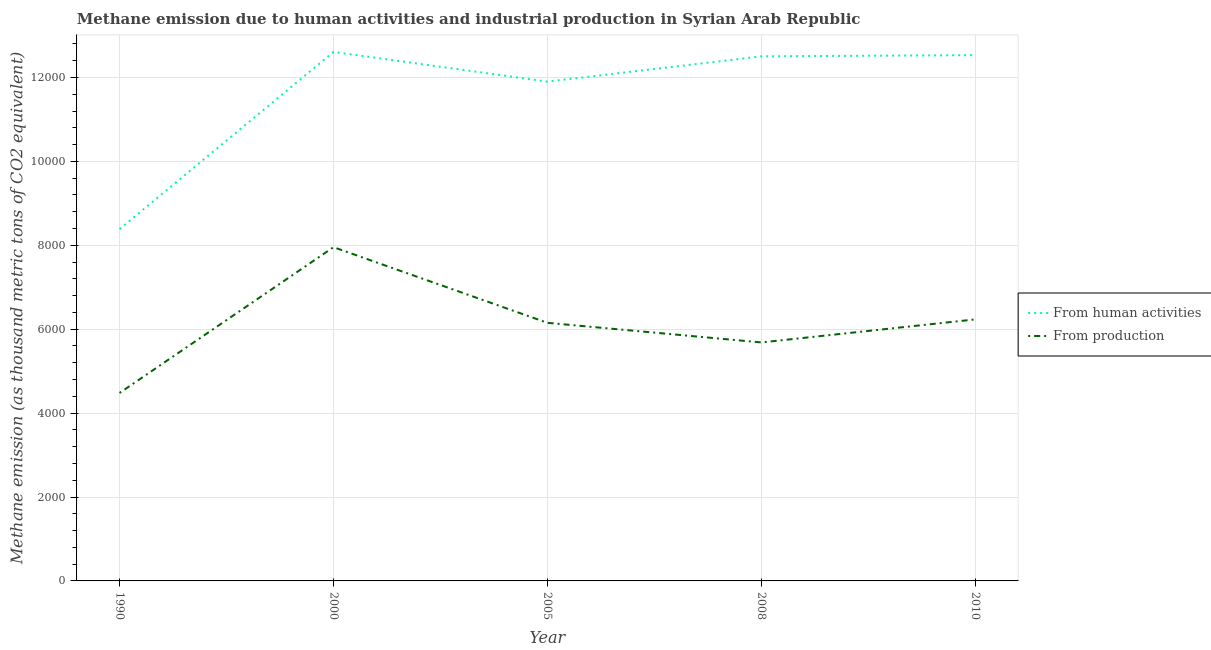Is the number of lines equal to the number of legend labels?
Your answer should be very brief. Yes. What is the amount of emissions from human activities in 2005?
Offer a terse response. 1.19e+04. Across all years, what is the maximum amount of emissions generated from industries?
Keep it short and to the point. 7954.6. Across all years, what is the minimum amount of emissions generated from industries?
Make the answer very short. 4480.2. In which year was the amount of emissions generated from industries maximum?
Your answer should be compact. 2000. What is the total amount of emissions from human activities in the graph?
Offer a terse response. 5.79e+04. What is the difference between the amount of emissions from human activities in 2005 and that in 2008?
Provide a short and direct response. -602.6. What is the difference between the amount of emissions from human activities in 2000 and the amount of emissions generated from industries in 2010?
Keep it short and to the point. 6375.2. What is the average amount of emissions generated from industries per year?
Your answer should be compact. 6100.92. In the year 2000, what is the difference between the amount of emissions from human activities and amount of emissions generated from industries?
Provide a succinct answer. 4654.2. In how many years, is the amount of emissions generated from industries greater than 2400 thousand metric tons?
Your answer should be very brief. 5. What is the ratio of the amount of emissions generated from industries in 1990 to that in 2008?
Offer a terse response. 0.79. What is the difference between the highest and the second highest amount of emissions from human activities?
Offer a terse response. 76.7. What is the difference between the highest and the lowest amount of emissions generated from industries?
Offer a very short reply. 3474.4. In how many years, is the amount of emissions from human activities greater than the average amount of emissions from human activities taken over all years?
Provide a short and direct response. 4. Does the amount of emissions from human activities monotonically increase over the years?
Ensure brevity in your answer.  No. Is the amount of emissions generated from industries strictly greater than the amount of emissions from human activities over the years?
Provide a succinct answer. No. What is the title of the graph?
Offer a terse response. Methane emission due to human activities and industrial production in Syrian Arab Republic. What is the label or title of the X-axis?
Provide a succinct answer. Year. What is the label or title of the Y-axis?
Provide a succinct answer. Methane emission (as thousand metric tons of CO2 equivalent). What is the Methane emission (as thousand metric tons of CO2 equivalent) in From human activities in 1990?
Your answer should be very brief. 8384.9. What is the Methane emission (as thousand metric tons of CO2 equivalent) in From production in 1990?
Provide a short and direct response. 4480.2. What is the Methane emission (as thousand metric tons of CO2 equivalent) in From human activities in 2000?
Keep it short and to the point. 1.26e+04. What is the Methane emission (as thousand metric tons of CO2 equivalent) of From production in 2000?
Keep it short and to the point. 7954.6. What is the Methane emission (as thousand metric tons of CO2 equivalent) in From human activities in 2005?
Provide a succinct answer. 1.19e+04. What is the Methane emission (as thousand metric tons of CO2 equivalent) of From production in 2005?
Provide a short and direct response. 6151.7. What is the Methane emission (as thousand metric tons of CO2 equivalent) in From human activities in 2008?
Offer a terse response. 1.25e+04. What is the Methane emission (as thousand metric tons of CO2 equivalent) of From production in 2008?
Your answer should be compact. 5684.5. What is the Methane emission (as thousand metric tons of CO2 equivalent) of From human activities in 2010?
Provide a succinct answer. 1.25e+04. What is the Methane emission (as thousand metric tons of CO2 equivalent) of From production in 2010?
Provide a succinct answer. 6233.6. Across all years, what is the maximum Methane emission (as thousand metric tons of CO2 equivalent) in From human activities?
Your answer should be very brief. 1.26e+04. Across all years, what is the maximum Methane emission (as thousand metric tons of CO2 equivalent) of From production?
Keep it short and to the point. 7954.6. Across all years, what is the minimum Methane emission (as thousand metric tons of CO2 equivalent) in From human activities?
Give a very brief answer. 8384.9. Across all years, what is the minimum Methane emission (as thousand metric tons of CO2 equivalent) of From production?
Make the answer very short. 4480.2. What is the total Methane emission (as thousand metric tons of CO2 equivalent) in From human activities in the graph?
Provide a succinct answer. 5.79e+04. What is the total Methane emission (as thousand metric tons of CO2 equivalent) of From production in the graph?
Provide a succinct answer. 3.05e+04. What is the difference between the Methane emission (as thousand metric tons of CO2 equivalent) of From human activities in 1990 and that in 2000?
Provide a short and direct response. -4223.9. What is the difference between the Methane emission (as thousand metric tons of CO2 equivalent) in From production in 1990 and that in 2000?
Provide a succinct answer. -3474.4. What is the difference between the Methane emission (as thousand metric tons of CO2 equivalent) in From human activities in 1990 and that in 2005?
Make the answer very short. -3516.3. What is the difference between the Methane emission (as thousand metric tons of CO2 equivalent) of From production in 1990 and that in 2005?
Ensure brevity in your answer.  -1671.5. What is the difference between the Methane emission (as thousand metric tons of CO2 equivalent) in From human activities in 1990 and that in 2008?
Provide a short and direct response. -4118.9. What is the difference between the Methane emission (as thousand metric tons of CO2 equivalent) of From production in 1990 and that in 2008?
Provide a short and direct response. -1204.3. What is the difference between the Methane emission (as thousand metric tons of CO2 equivalent) of From human activities in 1990 and that in 2010?
Provide a succinct answer. -4147.2. What is the difference between the Methane emission (as thousand metric tons of CO2 equivalent) in From production in 1990 and that in 2010?
Provide a short and direct response. -1753.4. What is the difference between the Methane emission (as thousand metric tons of CO2 equivalent) of From human activities in 2000 and that in 2005?
Your answer should be compact. 707.6. What is the difference between the Methane emission (as thousand metric tons of CO2 equivalent) of From production in 2000 and that in 2005?
Give a very brief answer. 1802.9. What is the difference between the Methane emission (as thousand metric tons of CO2 equivalent) of From human activities in 2000 and that in 2008?
Make the answer very short. 105. What is the difference between the Methane emission (as thousand metric tons of CO2 equivalent) in From production in 2000 and that in 2008?
Give a very brief answer. 2270.1. What is the difference between the Methane emission (as thousand metric tons of CO2 equivalent) of From human activities in 2000 and that in 2010?
Keep it short and to the point. 76.7. What is the difference between the Methane emission (as thousand metric tons of CO2 equivalent) of From production in 2000 and that in 2010?
Offer a very short reply. 1721. What is the difference between the Methane emission (as thousand metric tons of CO2 equivalent) of From human activities in 2005 and that in 2008?
Provide a succinct answer. -602.6. What is the difference between the Methane emission (as thousand metric tons of CO2 equivalent) in From production in 2005 and that in 2008?
Give a very brief answer. 467.2. What is the difference between the Methane emission (as thousand metric tons of CO2 equivalent) of From human activities in 2005 and that in 2010?
Your answer should be compact. -630.9. What is the difference between the Methane emission (as thousand metric tons of CO2 equivalent) of From production in 2005 and that in 2010?
Make the answer very short. -81.9. What is the difference between the Methane emission (as thousand metric tons of CO2 equivalent) in From human activities in 2008 and that in 2010?
Your response must be concise. -28.3. What is the difference between the Methane emission (as thousand metric tons of CO2 equivalent) of From production in 2008 and that in 2010?
Make the answer very short. -549.1. What is the difference between the Methane emission (as thousand metric tons of CO2 equivalent) in From human activities in 1990 and the Methane emission (as thousand metric tons of CO2 equivalent) in From production in 2000?
Your answer should be very brief. 430.3. What is the difference between the Methane emission (as thousand metric tons of CO2 equivalent) in From human activities in 1990 and the Methane emission (as thousand metric tons of CO2 equivalent) in From production in 2005?
Provide a short and direct response. 2233.2. What is the difference between the Methane emission (as thousand metric tons of CO2 equivalent) in From human activities in 1990 and the Methane emission (as thousand metric tons of CO2 equivalent) in From production in 2008?
Give a very brief answer. 2700.4. What is the difference between the Methane emission (as thousand metric tons of CO2 equivalent) of From human activities in 1990 and the Methane emission (as thousand metric tons of CO2 equivalent) of From production in 2010?
Offer a terse response. 2151.3. What is the difference between the Methane emission (as thousand metric tons of CO2 equivalent) of From human activities in 2000 and the Methane emission (as thousand metric tons of CO2 equivalent) of From production in 2005?
Provide a short and direct response. 6457.1. What is the difference between the Methane emission (as thousand metric tons of CO2 equivalent) in From human activities in 2000 and the Methane emission (as thousand metric tons of CO2 equivalent) in From production in 2008?
Offer a very short reply. 6924.3. What is the difference between the Methane emission (as thousand metric tons of CO2 equivalent) in From human activities in 2000 and the Methane emission (as thousand metric tons of CO2 equivalent) in From production in 2010?
Offer a very short reply. 6375.2. What is the difference between the Methane emission (as thousand metric tons of CO2 equivalent) in From human activities in 2005 and the Methane emission (as thousand metric tons of CO2 equivalent) in From production in 2008?
Offer a very short reply. 6216.7. What is the difference between the Methane emission (as thousand metric tons of CO2 equivalent) in From human activities in 2005 and the Methane emission (as thousand metric tons of CO2 equivalent) in From production in 2010?
Provide a succinct answer. 5667.6. What is the difference between the Methane emission (as thousand metric tons of CO2 equivalent) in From human activities in 2008 and the Methane emission (as thousand metric tons of CO2 equivalent) in From production in 2010?
Your answer should be very brief. 6270.2. What is the average Methane emission (as thousand metric tons of CO2 equivalent) of From human activities per year?
Ensure brevity in your answer.  1.16e+04. What is the average Methane emission (as thousand metric tons of CO2 equivalent) in From production per year?
Offer a very short reply. 6100.92. In the year 1990, what is the difference between the Methane emission (as thousand metric tons of CO2 equivalent) in From human activities and Methane emission (as thousand metric tons of CO2 equivalent) in From production?
Give a very brief answer. 3904.7. In the year 2000, what is the difference between the Methane emission (as thousand metric tons of CO2 equivalent) of From human activities and Methane emission (as thousand metric tons of CO2 equivalent) of From production?
Your answer should be compact. 4654.2. In the year 2005, what is the difference between the Methane emission (as thousand metric tons of CO2 equivalent) in From human activities and Methane emission (as thousand metric tons of CO2 equivalent) in From production?
Your response must be concise. 5749.5. In the year 2008, what is the difference between the Methane emission (as thousand metric tons of CO2 equivalent) of From human activities and Methane emission (as thousand metric tons of CO2 equivalent) of From production?
Offer a terse response. 6819.3. In the year 2010, what is the difference between the Methane emission (as thousand metric tons of CO2 equivalent) in From human activities and Methane emission (as thousand metric tons of CO2 equivalent) in From production?
Your response must be concise. 6298.5. What is the ratio of the Methane emission (as thousand metric tons of CO2 equivalent) in From human activities in 1990 to that in 2000?
Your response must be concise. 0.67. What is the ratio of the Methane emission (as thousand metric tons of CO2 equivalent) of From production in 1990 to that in 2000?
Your answer should be compact. 0.56. What is the ratio of the Methane emission (as thousand metric tons of CO2 equivalent) of From human activities in 1990 to that in 2005?
Your response must be concise. 0.7. What is the ratio of the Methane emission (as thousand metric tons of CO2 equivalent) in From production in 1990 to that in 2005?
Keep it short and to the point. 0.73. What is the ratio of the Methane emission (as thousand metric tons of CO2 equivalent) of From human activities in 1990 to that in 2008?
Ensure brevity in your answer.  0.67. What is the ratio of the Methane emission (as thousand metric tons of CO2 equivalent) of From production in 1990 to that in 2008?
Make the answer very short. 0.79. What is the ratio of the Methane emission (as thousand metric tons of CO2 equivalent) of From human activities in 1990 to that in 2010?
Provide a succinct answer. 0.67. What is the ratio of the Methane emission (as thousand metric tons of CO2 equivalent) of From production in 1990 to that in 2010?
Make the answer very short. 0.72. What is the ratio of the Methane emission (as thousand metric tons of CO2 equivalent) in From human activities in 2000 to that in 2005?
Give a very brief answer. 1.06. What is the ratio of the Methane emission (as thousand metric tons of CO2 equivalent) in From production in 2000 to that in 2005?
Your answer should be very brief. 1.29. What is the ratio of the Methane emission (as thousand metric tons of CO2 equivalent) in From human activities in 2000 to that in 2008?
Make the answer very short. 1.01. What is the ratio of the Methane emission (as thousand metric tons of CO2 equivalent) of From production in 2000 to that in 2008?
Keep it short and to the point. 1.4. What is the ratio of the Methane emission (as thousand metric tons of CO2 equivalent) of From production in 2000 to that in 2010?
Offer a very short reply. 1.28. What is the ratio of the Methane emission (as thousand metric tons of CO2 equivalent) in From human activities in 2005 to that in 2008?
Your answer should be compact. 0.95. What is the ratio of the Methane emission (as thousand metric tons of CO2 equivalent) in From production in 2005 to that in 2008?
Make the answer very short. 1.08. What is the ratio of the Methane emission (as thousand metric tons of CO2 equivalent) in From human activities in 2005 to that in 2010?
Ensure brevity in your answer.  0.95. What is the ratio of the Methane emission (as thousand metric tons of CO2 equivalent) in From production in 2005 to that in 2010?
Your response must be concise. 0.99. What is the ratio of the Methane emission (as thousand metric tons of CO2 equivalent) of From human activities in 2008 to that in 2010?
Offer a terse response. 1. What is the ratio of the Methane emission (as thousand metric tons of CO2 equivalent) of From production in 2008 to that in 2010?
Keep it short and to the point. 0.91. What is the difference between the highest and the second highest Methane emission (as thousand metric tons of CO2 equivalent) in From human activities?
Keep it short and to the point. 76.7. What is the difference between the highest and the second highest Methane emission (as thousand metric tons of CO2 equivalent) of From production?
Give a very brief answer. 1721. What is the difference between the highest and the lowest Methane emission (as thousand metric tons of CO2 equivalent) of From human activities?
Give a very brief answer. 4223.9. What is the difference between the highest and the lowest Methane emission (as thousand metric tons of CO2 equivalent) of From production?
Offer a terse response. 3474.4. 